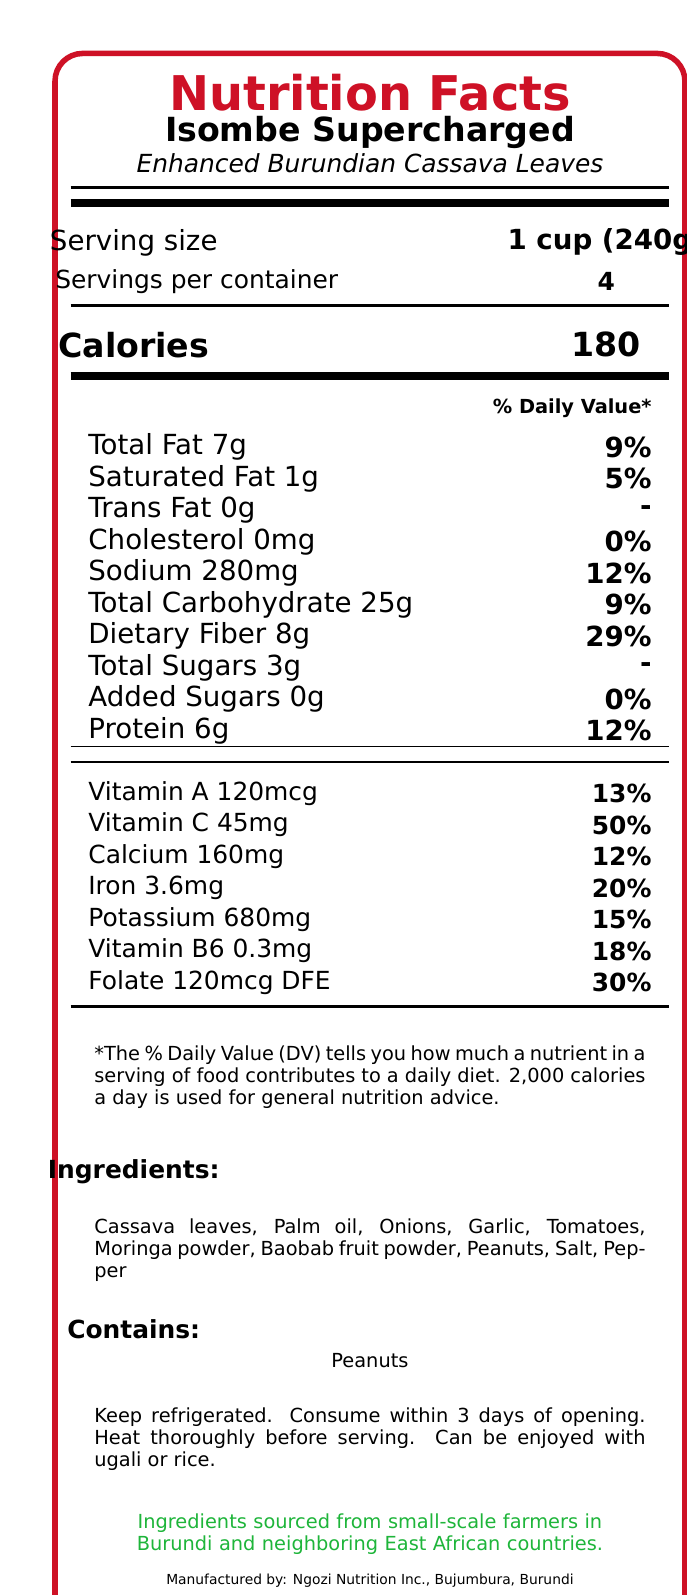what is the product name? The product name is clearly stated at the beginning of the document.
Answer: Isombe Supercharged - Enhanced Burundian Cassava Leaves what is the serving size? The serving size is labeled as "1 cup (240g)" in the nutritional facts.
Answer: 1 cup (240g) how many calories are in one serving? The document lists the calories per serving as 180.
Answer: 180 which ingredient is listed first? The ingredient list starts with "Cassava leaves."
Answer: Cassava leaves what should you do with the dish before serving? The preparation tip in the additional information instructs to heat the dish thoroughly before serving.
Answer: Heat thoroughly before serving. what percentage of Daily Value of Vitamin C does one serving provide? A. 12% B. 29% C. 50% D. 13% The document states that one serving provides 45mg of Vitamin C, which is 50% of the Daily Value.
Answer: C. 50% who manufactures the product? A. African Diaspora Foods B. Ngozi Nutrition Inc. C. Moringa Power D. East African Foods The document mentions that the product is manufactured by Ngozi Nutrition Inc., Bujumbura, Burundi.
Answer: B. Ngozi Nutrition Inc. does the product contain trans fat? The trans fat content is listed as 0g in the nutritional information.
Answer: No how many servings are in one container? The document states that there are 4 servings per container.
Answer: 4 describe the entire document. The document provides comprehensive nutritional and additional product information for "Isombe Supercharged - Enhanced Burundian Cassava Leaves."
Answer: The document serves as a detailed Nutrition Facts Label for "Isombe Supercharged - Enhanced Burundian Cassava Leaves." It includes the serving size, servings per container, calories, and detailed nutritional content such as total fat, cholesterol, sodium, carbohydrates, and vitamins. Ingredients and allergen information are listed, followed by tips for storage and preparation. There’s also a note on the cultural significance of the dish and a sustainability note about sourcing ingredients from small-scale farmers. Manufacturing and distribution details are provided at the end. what is the daily value percentage for dietary fiber per serving? The dietary fiber per serving is listed as 8g, which corresponds to 29% of the Daily Value.
Answer: 29% how much folate is in one serving? The folate content per serving is listed as 120mcg DFE in the nutritional information.
Answer: 120mcg DFE which vitamin has the highest daily value percentage in one serving? A. Vitamin A B. Vitamin C C. Vitamin B6 D. Folate Vitamin C provides 50% of the Daily Value per serving, which is the highest among the listed vitamins.
Answer: B. Vitamin C what are the instructions for storage? The storage instructions specify to keep the product refrigerated and consume within 3 days of opening.
Answer: Keep refrigerated. Consume within 3 days of opening. what is the sustainability note about the product? The sustainability note mentions that ingredients are sourced from small-scale farmers in Burundi and neighboring East African countries.
Answer: Ingredients sourced from small-scale farmers in Burundi and neighboring East African countries. what is the total amount of sugars in one serving? The total sugars per serving are listed as 3g in the nutritional information.
Answer: 3g are peanuts listed as an allergen? Peanuts are explicitly mentioned in the allergen information section.
Answer: Yes what is the description of the product? The additional info describes the product as a nutrient-dense version of the traditional Burundian dish, enhanced with superfoods native to Africa.
Answer: A nutrient-dense version of the traditional Burundian dish, enhanced with superfoods native to Africa. how many grams of protein are in each serving? Each serving contains 6 grams of protein according to the nutritional information.
Answer: 6g what are some of the superfoods added to enhance the traditional dish? According to the ingredient list, Moringa powder and Baobab fruit powder are some of the superfoods added.
Answer: Moringa powder, Baobab fruit powder what is the total daily value percentage of calcium provided in one serving? The calcium content per serving is listed as 160mg, which is 12% of the Daily Value.
Answer: 12% could you determine the price of the product from the document? The document does not provide any information about the price of the product.
Answer: Not enough information 